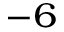Convert formula to latex. <formula><loc_0><loc_0><loc_500><loc_500>^ { - 6 }</formula> 